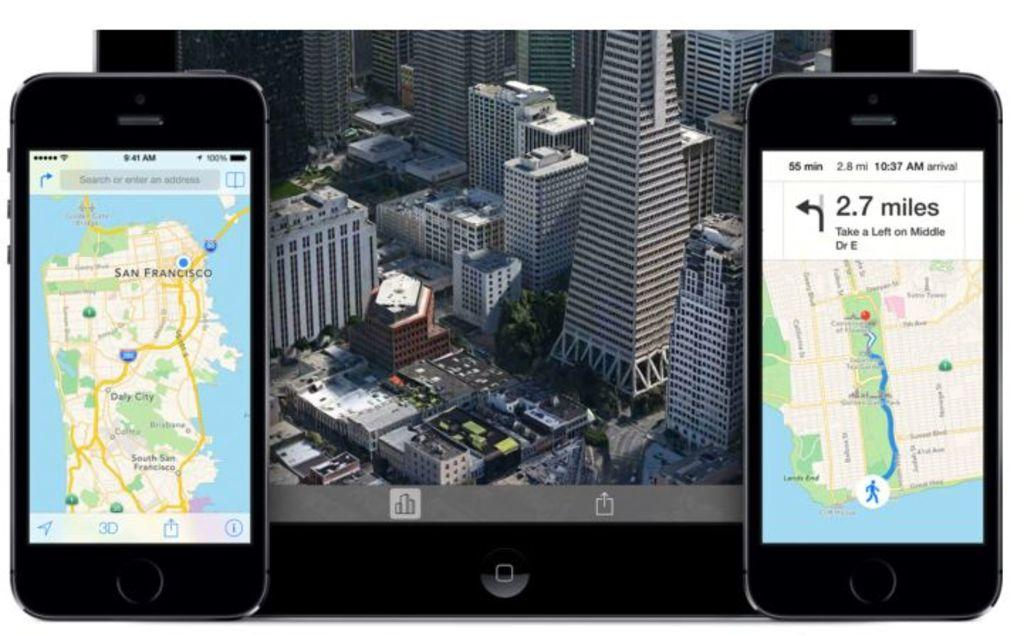<image>
Provide a brief description of the given image. two iphones over an image of a city with one showing directions to take a left in 2.7 miles 